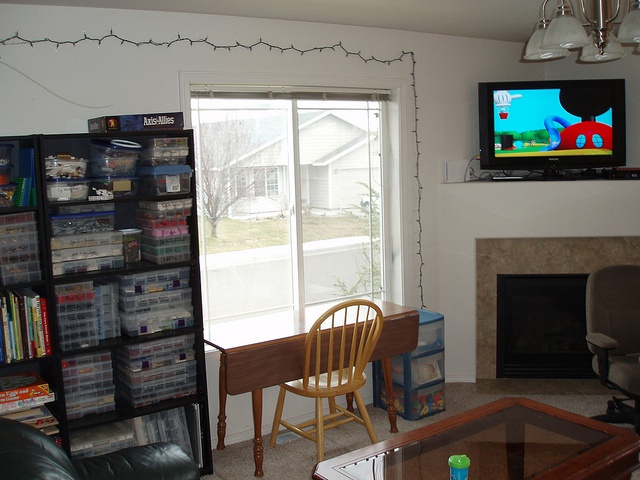Describe the objects in this image and their specific colors. I can see tv in gray, black, cyan, brown, and lightblue tones, chair in gray, maroon, and olive tones, chair in gray and black tones, couch in gray, black, purple, and darkgray tones, and book in gray, black, maroon, and darkgray tones in this image. 